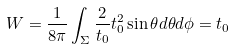<formula> <loc_0><loc_0><loc_500><loc_500>W = \frac { 1 } { 8 \pi } \int _ { \Sigma } \frac { 2 } { t _ { 0 } } t _ { 0 } ^ { 2 } \sin \theta d \theta d \phi = t _ { 0 }</formula> 